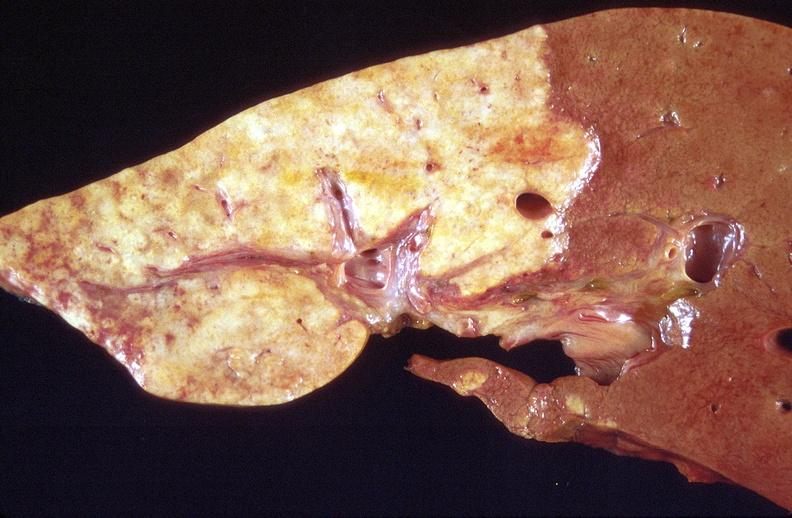does previous slide from this case show cholangiocarcinoma?
Answer the question using a single word or phrase. No 